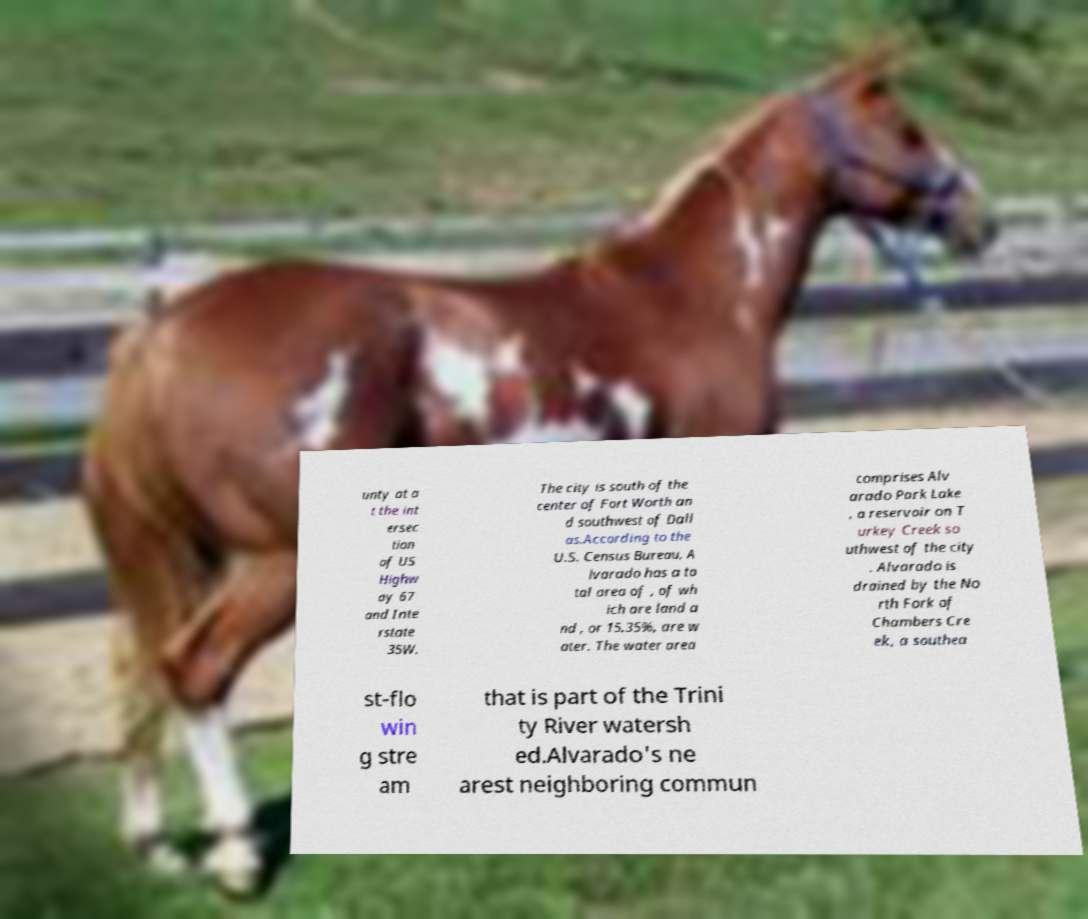Could you assist in decoding the text presented in this image and type it out clearly? unty at a t the int ersec tion of US Highw ay 67 and Inte rstate 35W. The city is south of the center of Fort Worth an d southwest of Dall as.According to the U.S. Census Bureau, A lvarado has a to tal area of , of wh ich are land a nd , or 15.35%, are w ater. The water area comprises Alv arado Park Lake , a reservoir on T urkey Creek so uthwest of the city . Alvarado is drained by the No rth Fork of Chambers Cre ek, a southea st-flo win g stre am that is part of the Trini ty River watersh ed.Alvarado's ne arest neighboring commun 